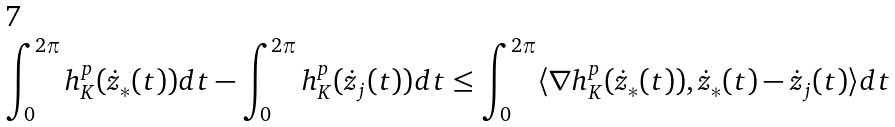Convert formula to latex. <formula><loc_0><loc_0><loc_500><loc_500>\int _ { 0 } ^ { 2 \pi } h _ { K } ^ { p } ( { \dot { z } } _ { * } ( t ) ) d t - \int _ { 0 } ^ { 2 \pi } h _ { K } ^ { p } ( { \dot { z } } _ { j } ( t ) ) d t \leq \int _ { 0 } ^ { 2 \pi } \langle \nabla h _ { K } ^ { p } ( { \dot { z } } _ { * } ( t ) ) , { \dot { z } } _ { * } ( t ) - { \dot { z } } _ { j } ( t ) \rangle d t</formula> 